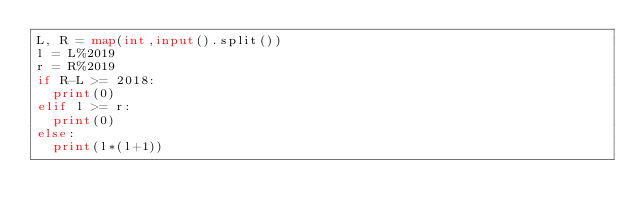<code> <loc_0><loc_0><loc_500><loc_500><_Python_>L, R = map(int,input().split())
l = L%2019
r = R%2019
if R-L >= 2018:
  print(0)
elif l >= r:
  print(0)
else:
  print(l*(l+1))</code> 